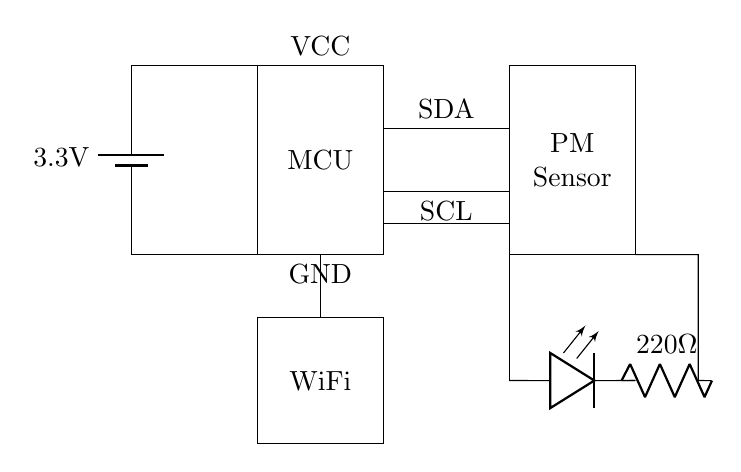What is the voltage provided by the battery? The circuit diagram shows a battery labeled with a voltage of 3.3V. This indicates the potential difference supplied to the circuit.
Answer: 3.3V What is the purpose of the microcontroller in this circuit? The microcontroller (MCU) acts as the central processing unit that receives data from the particulate matter sensor and possibly controls other components like the WiFi module and LED indicator based on that data.
Answer: Control How is the particulate matter sensor connected to the microcontroller? The PM sensor is connected to the microcontroller via two lines labeled SDA (for data) and SCL (for clock), which are standard communication lines used in I2C communication.
Answer: SDA and SCL What component indicates air quality in this circuit? The LED connected to the PM sensor serves as an indicator for air quality, likely lighting up based on the data provided by the sensor regarding particulate matter levels.
Answer: LED What is the resistance value of the resistor connected to the LED? The circuit shows a resistor with a value of 220 Ohms connected in series with the LED, which helps limit the current passing through the LED to protect it.
Answer: 220 Ohms How does the WiFi module relate to the microcontroller in the circuit? The WiFi module is connected to the microcontroller, allowing the microcontroller to send data from the PM sensor over WiFi, which enables remote monitoring of air quality.
Answer: Data transmission 